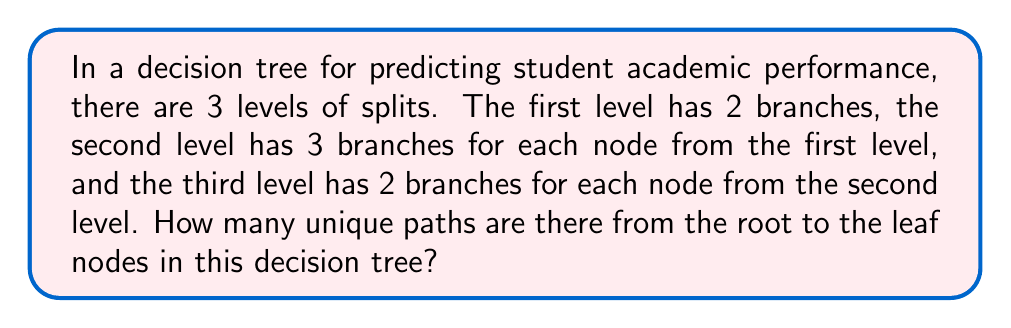Solve this math problem. Let's approach this step-by-step:

1) First, let's visualize the structure of the decision tree:
   - Level 1: 2 branches
   - Level 2: 3 branches for each node from Level 1
   - Level 3: 2 branches for each node from Level 2

2) To find the total number of unique paths, we need to multiply the number of choices at each level:

   $$\text{Total Paths} = \text{Choices at Level 1} \times \text{Choices at Level 2} \times \text{Choices at Level 3}$$

3) Let's calculate each part:
   - Choices at Level 1: 2
   - Choices at Level 2: 3
   - Choices at Level 3: 2

4) Now, let's multiply these together:

   $$\text{Total Paths} = 2 \times 3 \times 2 = 12$$

5) Therefore, there are 12 unique paths from the root to the leaf nodes in this decision tree.

This result can be interpreted as the number of different ways the model can classify a student's performance based on the given features and decision points in the tree.
Answer: 12 paths 